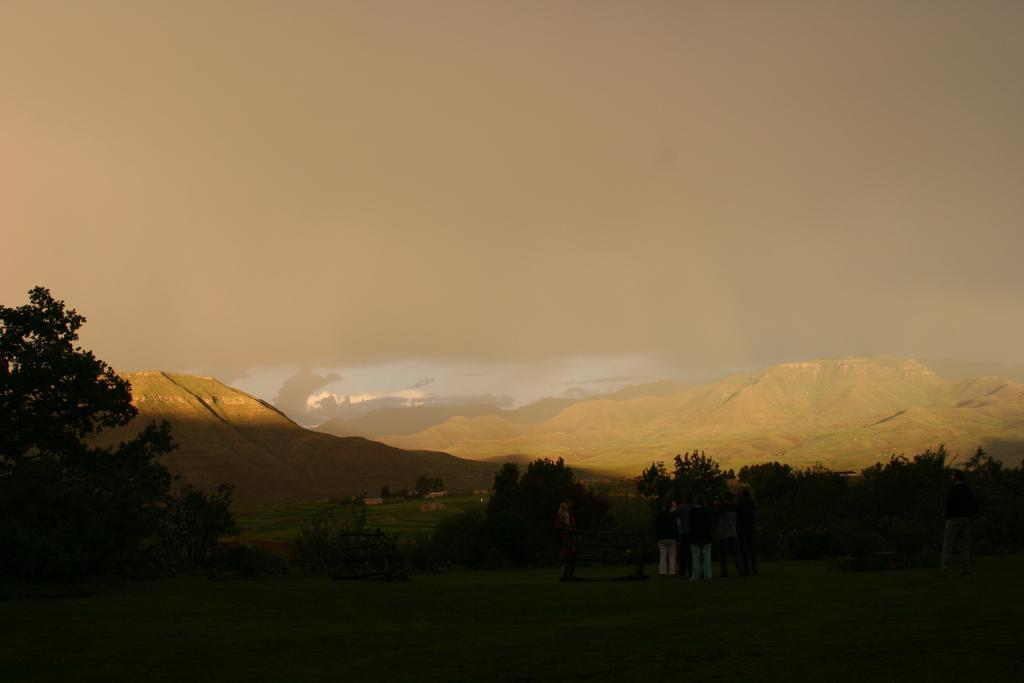Describe this image in one or two sentences. In this picture we can see some people standing here, there are some trees here, at the bottom there is grass, we can see some hills, there is sky at the top of the picture. 